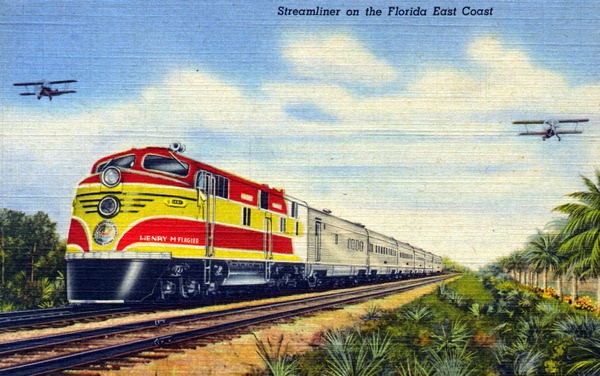Describe the objects in this image and their specific colors. I can see train in gray, black, gold, darkgray, and brown tones, airplane in gray, lightblue, and darkgray tones, and airplane in gray, darkgray, black, and navy tones in this image. 